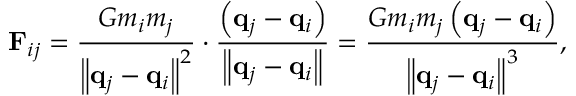Convert formula to latex. <formula><loc_0><loc_0><loc_500><loc_500>F _ { i j } = { \frac { G m _ { i } m _ { j } } { \left \| q _ { j } - q _ { i } \right \| ^ { 2 } } } \cdot { \frac { \left ( q _ { j } - q _ { i } \right ) } { \left \| q _ { j } - q _ { i } \right \| } } = { \frac { G m _ { i } m _ { j } \left ( q _ { j } - q _ { i } \right ) } { \left \| q _ { j } - q _ { i } \right \| ^ { 3 } } } ,</formula> 